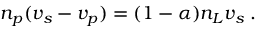Convert formula to latex. <formula><loc_0><loc_0><loc_500><loc_500>n _ { p } ( v _ { s } - v _ { p } ) = ( 1 - \alpha ) n _ { L } v _ { s } \, .</formula> 